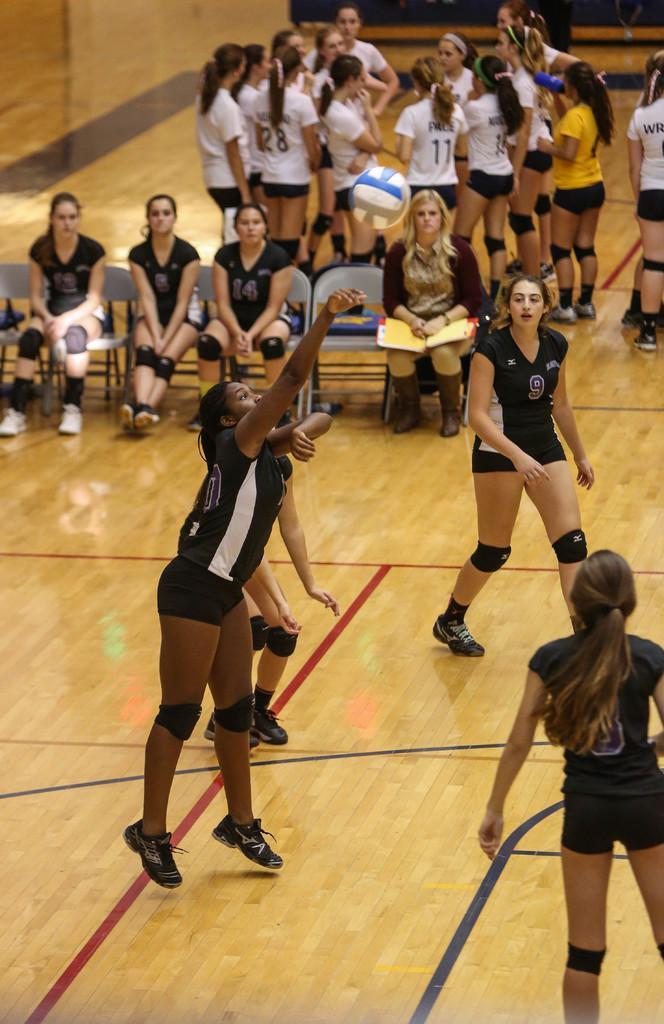Could you give a brief overview of what you see in this image? In this image there are a few girls playing with a football on the ground, back of them there are a few girls sitting on the chairs and some are standing. 